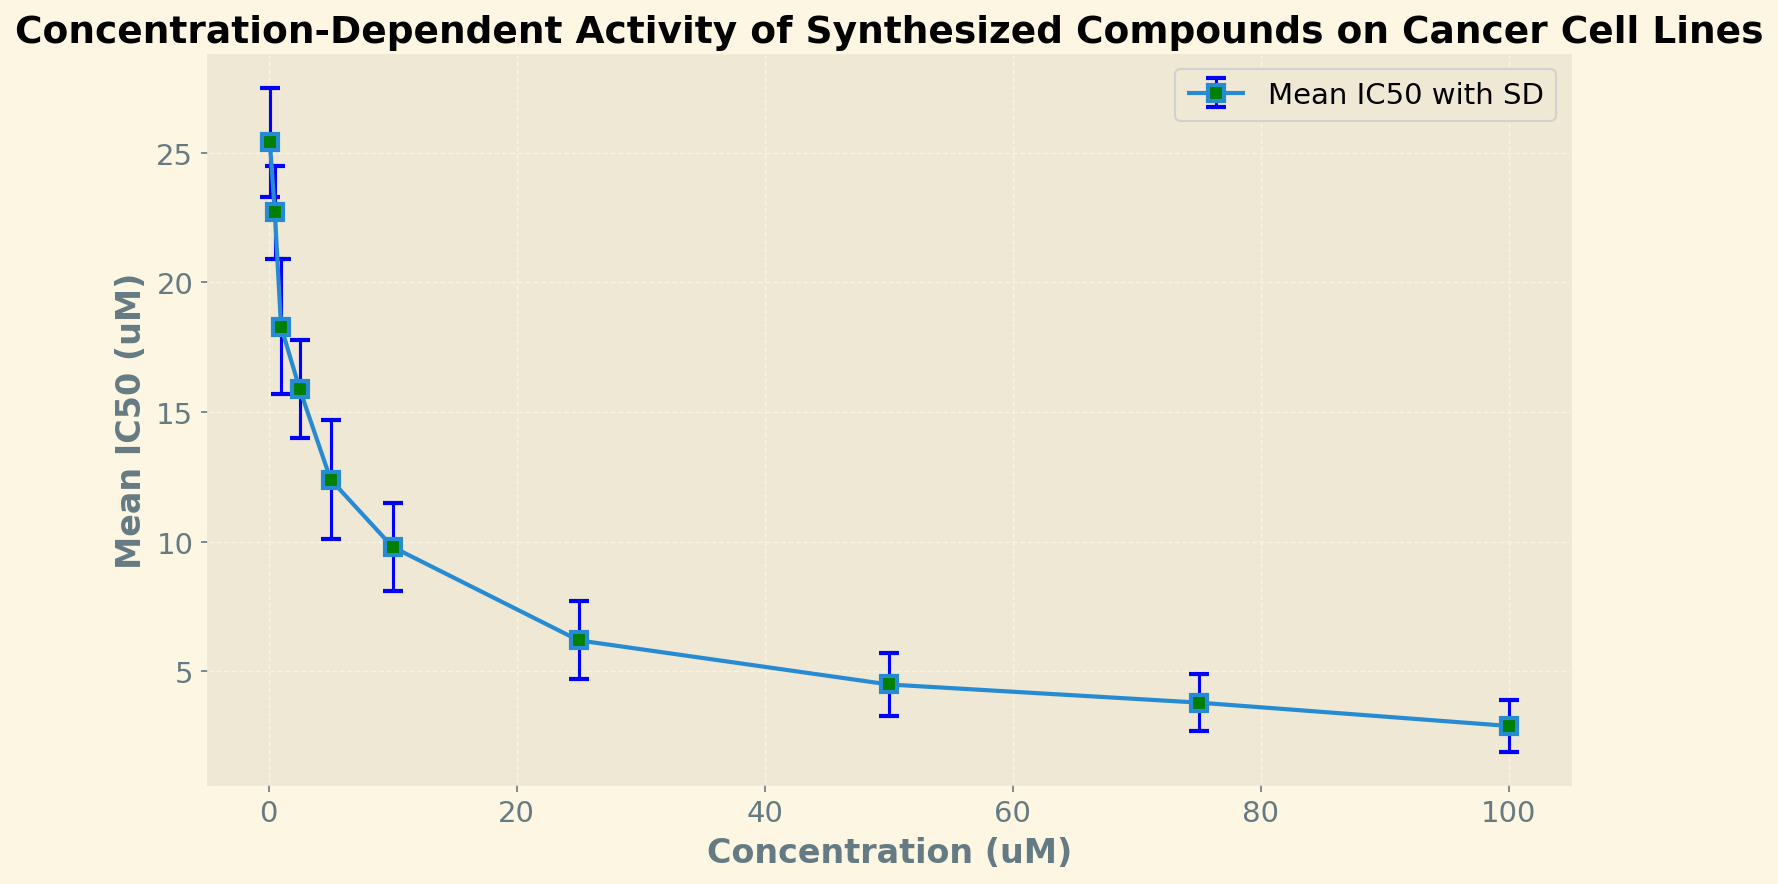What is the mean IC50 value at a concentration of 5.0 μM? At a concentration of 5.0 μM, the plot shows a mean IC50 value represented by the position of the marker on the y-axis.
Answer: 12.4 μM How does the mean IC50 value change as the concentration increases from 1.0 μM to 10.0 μM? To observe the change, compare the mean IC50 values at 1.0 μM and 10.0 μM. At 1.0 μM, the mean IC50 is 18.3 μM, and at 10.0 μM, it is 9.8 μM. The IC50 value decreases as the concentration increases.
Answer: Decreases What is the difference in mean IC50 values between concentrations of 25.0 μM and 50.0 μM? Subtract the mean IC50 value at 50.0 μM from the mean IC50 value at 25.0 μM. For 25.0 μM, the mean IC50 is 6.2 μM, and for 50.0 μM, it is 4.5 μM. The difference is 6.2 - 4.5 = 1.7 μM.
Answer: 1.7 μM Among the concentrations listed, which one has the highest variability in IC50 values? Examine the standard deviation values in the plot. The highest standard deviation is the marker with the largest error bar, which is at 1.0 μM with a standard deviation of 2.6 μM.
Answer: 1.0 μM How does the variability in IC50 values (standard deviation) change as concentration increases from 0.1 μM to 100.0 μM? Observe the error bars at these two concentrations. The standard deviation at 0.1 μM is 2.1 μM, and at 100.0 μM, it is 1.0 μM. The variability decreases as the concentration increases.
Answer: Decreases Which concentration has the lowest mean IC50 value, and what is it? Identify the marker corresponding to the lowest mean IC50 value on the y-axis. This happens at 100.0 μM, where the mean IC50 value is 2.9 μM.
Answer: 100.0 μM, 2.9 μM What is the trend displayed by the mean IC50 values as the concentration increases? Analyze the overall trend of the mean IC50 values on the plot. The mean IC50 values consistently decrease as the concentration increases.
Answer: Decreasing trend 